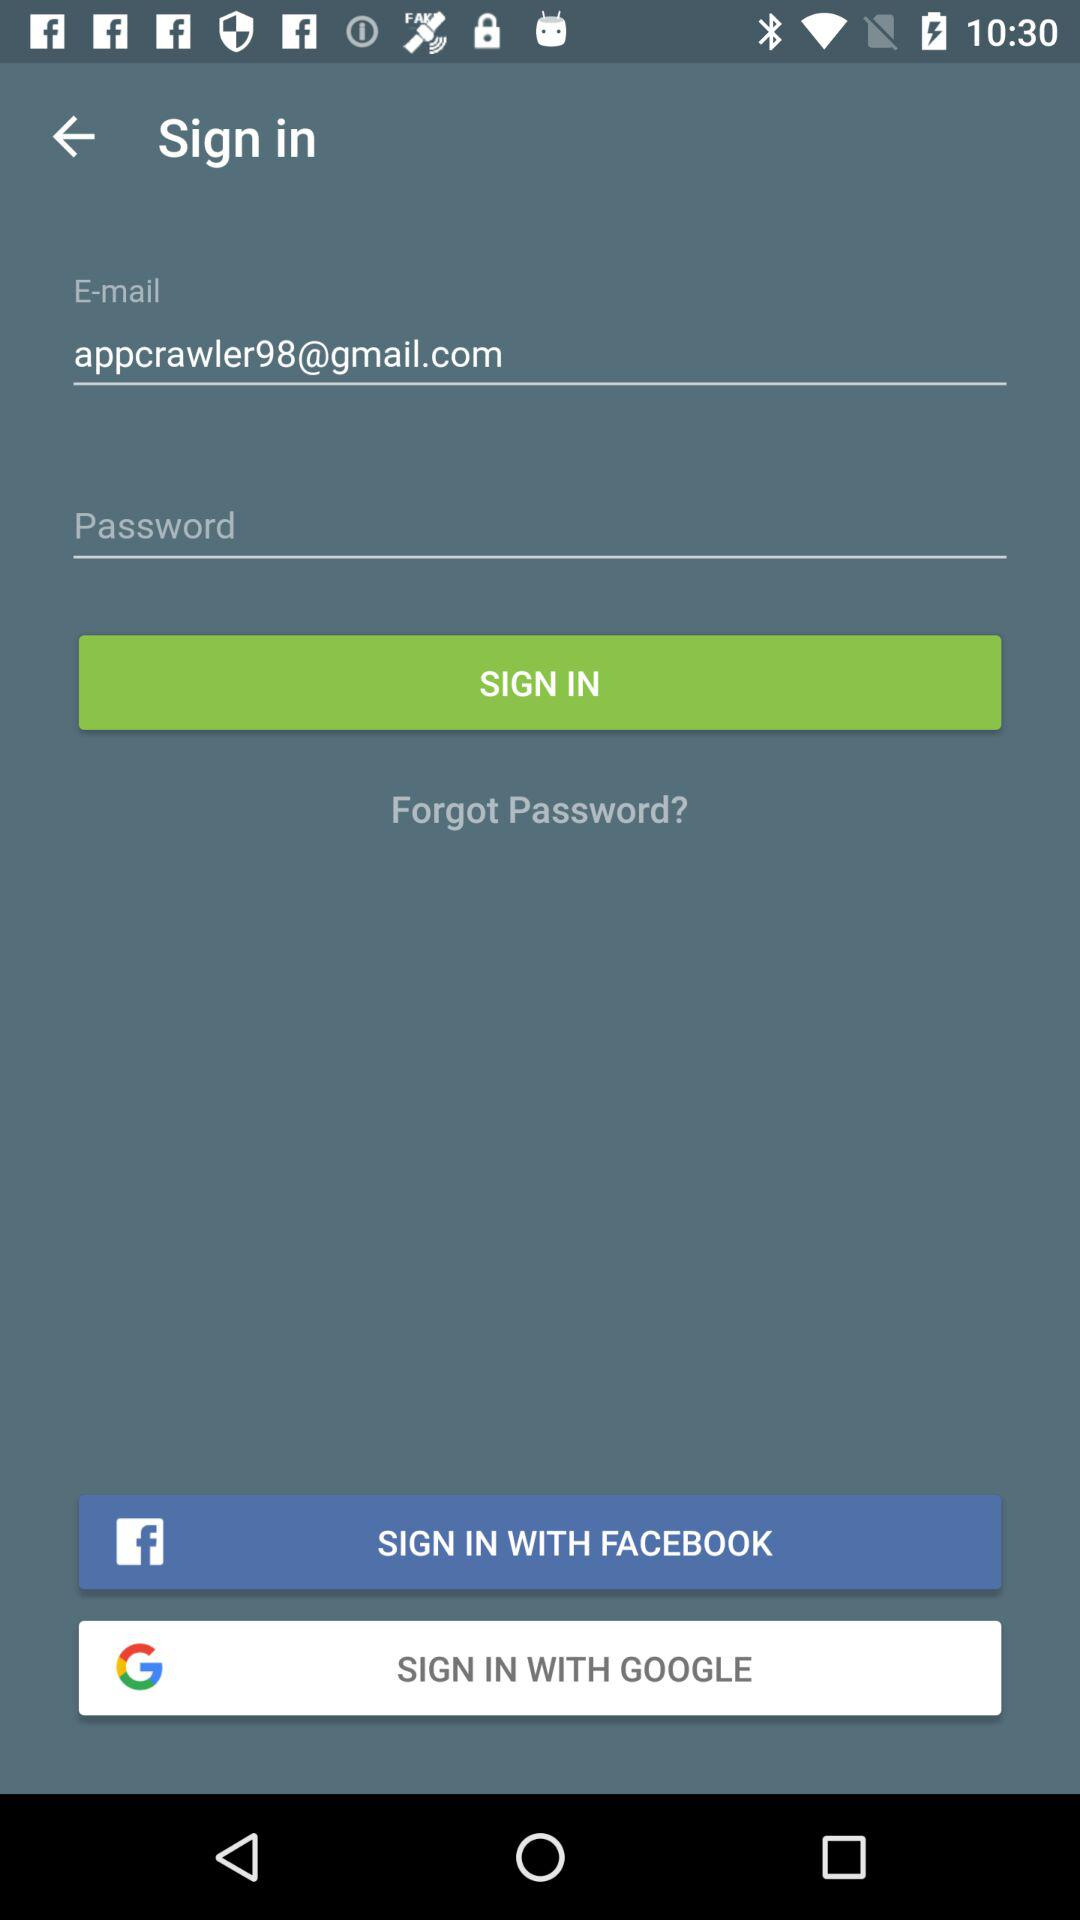By which app can we sign in? You can sign in with "FACEBOOK" and "GOOGLE". 